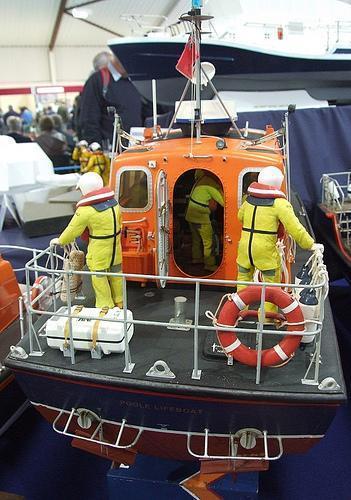Who are the men wearing yellow?
Choose the correct response, then elucidate: 'Answer: answer
Rationale: rationale.'
Options: Crew, doctors, chefs, students. Answer: crew.
Rationale: They are the crew on the boat. 